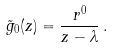Convert formula to latex. <formula><loc_0><loc_0><loc_500><loc_500>\tilde { g } _ { 0 } ( z ) = { \frac { r ^ { 0 } } { z - \lambda } } \, .</formula> 